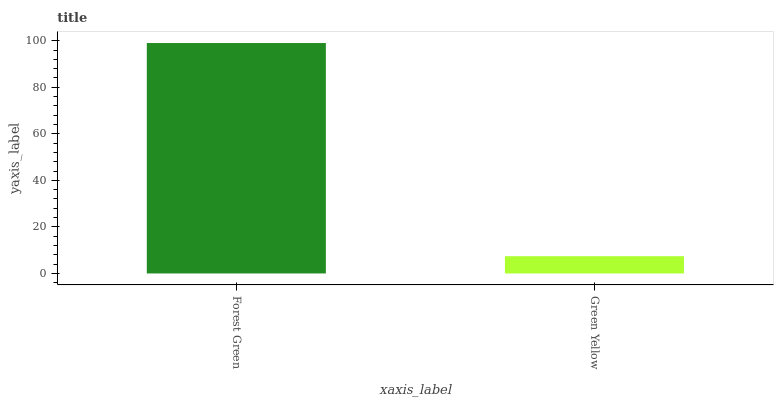Is Green Yellow the minimum?
Answer yes or no. Yes. Is Forest Green the maximum?
Answer yes or no. Yes. Is Green Yellow the maximum?
Answer yes or no. No. Is Forest Green greater than Green Yellow?
Answer yes or no. Yes. Is Green Yellow less than Forest Green?
Answer yes or no. Yes. Is Green Yellow greater than Forest Green?
Answer yes or no. No. Is Forest Green less than Green Yellow?
Answer yes or no. No. Is Forest Green the high median?
Answer yes or no. Yes. Is Green Yellow the low median?
Answer yes or no. Yes. Is Green Yellow the high median?
Answer yes or no. No. Is Forest Green the low median?
Answer yes or no. No. 